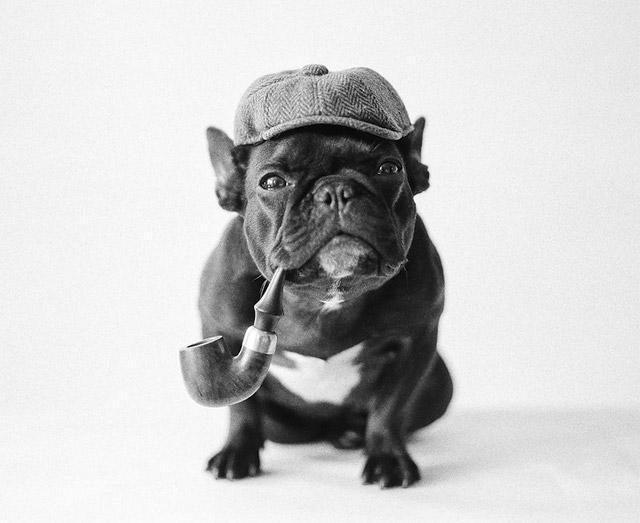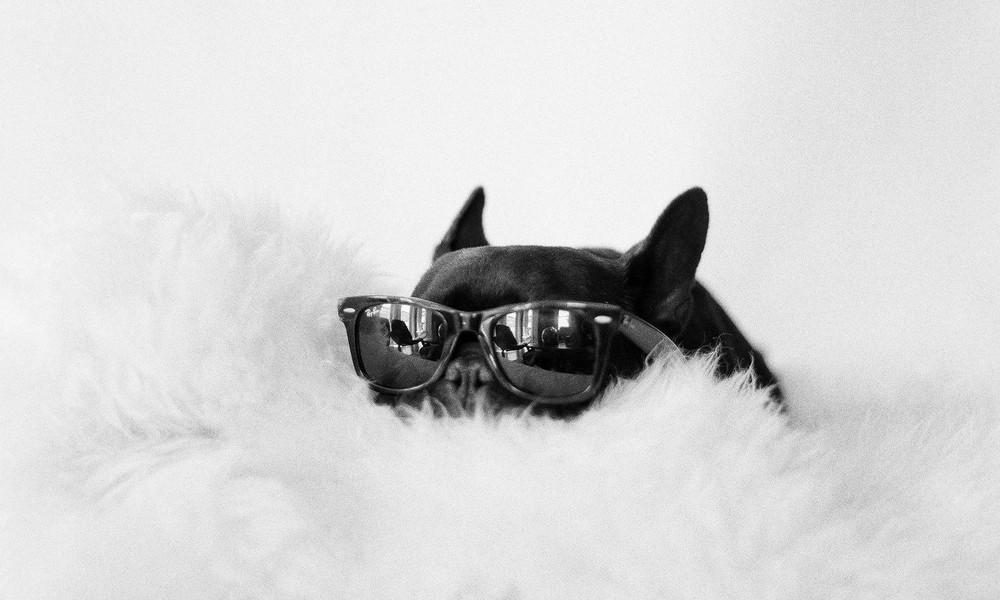The first image is the image on the left, the second image is the image on the right. Evaluate the accuracy of this statement regarding the images: "In one of the images the dog is wearing a hat.". Is it true? Answer yes or no. Yes. 